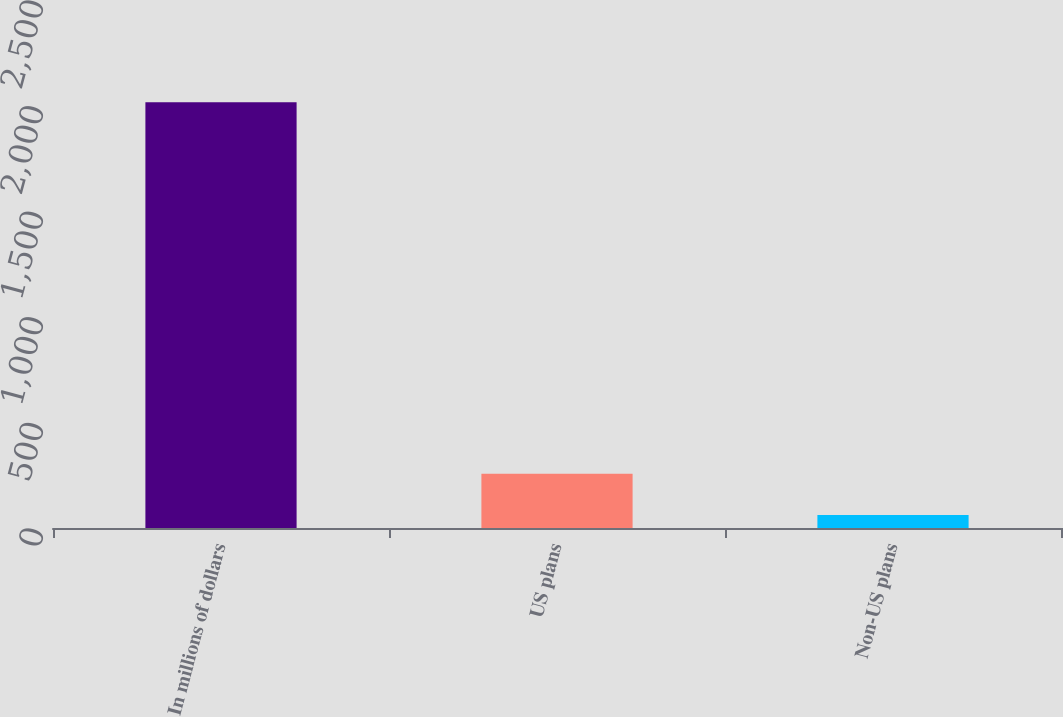Convert chart. <chart><loc_0><loc_0><loc_500><loc_500><bar_chart><fcel>In millions of dollars<fcel>US plans<fcel>Non-US plans<nl><fcel>2016<fcel>256.5<fcel>61<nl></chart> 